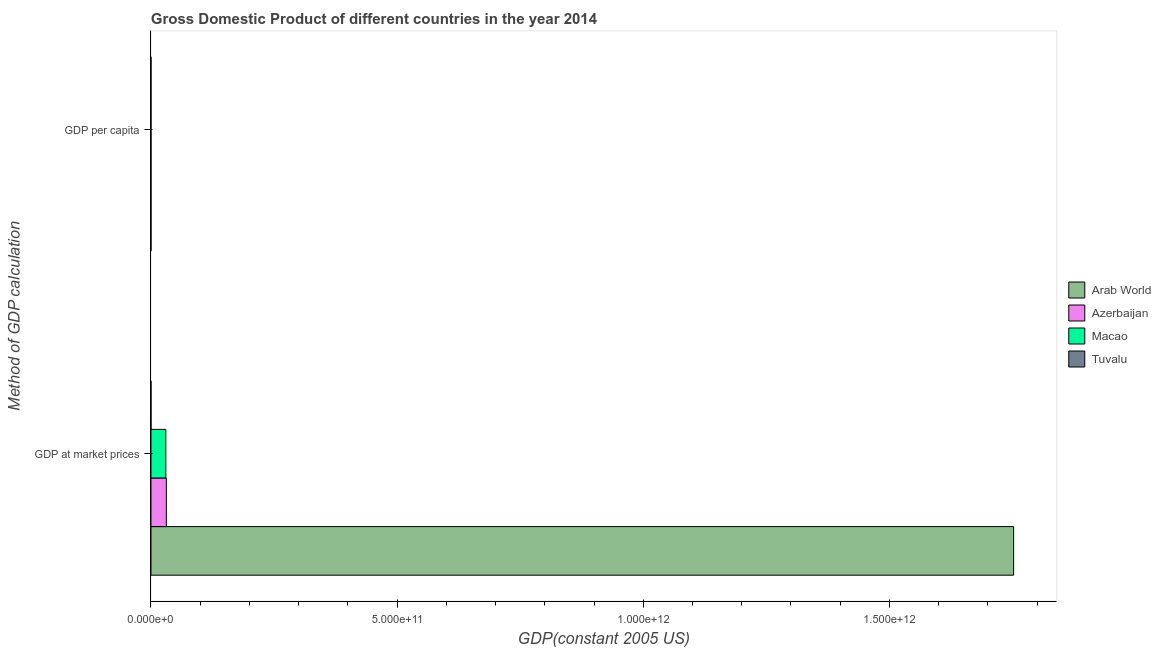Are the number of bars per tick equal to the number of legend labels?
Offer a terse response. Yes. How many bars are there on the 2nd tick from the top?
Keep it short and to the point. 4. What is the label of the 2nd group of bars from the top?
Ensure brevity in your answer.  GDP at market prices. What is the gdp at market prices in Arab World?
Keep it short and to the point. 1.75e+12. Across all countries, what is the maximum gdp at market prices?
Ensure brevity in your answer.  1.75e+12. Across all countries, what is the minimum gdp per capita?
Your answer should be compact. 2701.74. In which country was the gdp at market prices maximum?
Your answer should be compact. Arab World. In which country was the gdp at market prices minimum?
Give a very brief answer. Tuvalu. What is the total gdp per capita in the graph?
Your answer should be very brief. 6.28e+04. What is the difference between the gdp at market prices in Tuvalu and that in Macao?
Your answer should be very brief. -3.02e+1. What is the difference between the gdp at market prices in Azerbaijan and the gdp per capita in Tuvalu?
Offer a very short reply. 3.12e+1. What is the average gdp per capita per country?
Your answer should be very brief. 1.57e+04. What is the difference between the gdp at market prices and gdp per capita in Macao?
Give a very brief answer. 3.02e+1. In how many countries, is the gdp per capita greater than 1400000000000 US$?
Provide a short and direct response. 0. What is the ratio of the gdp at market prices in Arab World to that in Tuvalu?
Your answer should be compact. 6.56e+04. Is the gdp per capita in Macao less than that in Azerbaijan?
Your answer should be compact. No. What does the 1st bar from the top in GDP at market prices represents?
Offer a terse response. Tuvalu. What does the 1st bar from the bottom in GDP per capita represents?
Make the answer very short. Arab World. How many bars are there?
Your response must be concise. 8. How many countries are there in the graph?
Provide a short and direct response. 4. What is the difference between two consecutive major ticks on the X-axis?
Make the answer very short. 5.00e+11. Are the values on the major ticks of X-axis written in scientific E-notation?
Provide a succinct answer. Yes. Does the graph contain any zero values?
Ensure brevity in your answer.  No. Does the graph contain grids?
Keep it short and to the point. No. Where does the legend appear in the graph?
Provide a short and direct response. Center right. How many legend labels are there?
Offer a very short reply. 4. How are the legend labels stacked?
Keep it short and to the point. Vertical. What is the title of the graph?
Keep it short and to the point. Gross Domestic Product of different countries in the year 2014. What is the label or title of the X-axis?
Make the answer very short. GDP(constant 2005 US). What is the label or title of the Y-axis?
Provide a short and direct response. Method of GDP calculation. What is the GDP(constant 2005 US) of Arab World in GDP at market prices?
Keep it short and to the point. 1.75e+12. What is the GDP(constant 2005 US) in Azerbaijan in GDP at market prices?
Ensure brevity in your answer.  3.12e+1. What is the GDP(constant 2005 US) in Macao in GDP at market prices?
Give a very brief answer. 3.02e+1. What is the GDP(constant 2005 US) of Tuvalu in GDP at market prices?
Give a very brief answer. 2.67e+07. What is the GDP(constant 2005 US) in Arab World in GDP per capita?
Keep it short and to the point. 4548.53. What is the GDP(constant 2005 US) in Azerbaijan in GDP per capita?
Offer a very short reply. 3275.71. What is the GDP(constant 2005 US) of Macao in GDP per capita?
Offer a terse response. 5.23e+04. What is the GDP(constant 2005 US) of Tuvalu in GDP per capita?
Your answer should be very brief. 2701.74. Across all Method of GDP calculation, what is the maximum GDP(constant 2005 US) of Arab World?
Make the answer very short. 1.75e+12. Across all Method of GDP calculation, what is the maximum GDP(constant 2005 US) of Azerbaijan?
Your answer should be compact. 3.12e+1. Across all Method of GDP calculation, what is the maximum GDP(constant 2005 US) in Macao?
Ensure brevity in your answer.  3.02e+1. Across all Method of GDP calculation, what is the maximum GDP(constant 2005 US) of Tuvalu?
Ensure brevity in your answer.  2.67e+07. Across all Method of GDP calculation, what is the minimum GDP(constant 2005 US) of Arab World?
Make the answer very short. 4548.53. Across all Method of GDP calculation, what is the minimum GDP(constant 2005 US) of Azerbaijan?
Your answer should be compact. 3275.71. Across all Method of GDP calculation, what is the minimum GDP(constant 2005 US) in Macao?
Offer a very short reply. 5.23e+04. Across all Method of GDP calculation, what is the minimum GDP(constant 2005 US) of Tuvalu?
Offer a terse response. 2701.74. What is the total GDP(constant 2005 US) of Arab World in the graph?
Provide a short and direct response. 1.75e+12. What is the total GDP(constant 2005 US) in Azerbaijan in the graph?
Provide a succinct answer. 3.12e+1. What is the total GDP(constant 2005 US) in Macao in the graph?
Your response must be concise. 3.02e+1. What is the total GDP(constant 2005 US) in Tuvalu in the graph?
Your answer should be compact. 2.67e+07. What is the difference between the GDP(constant 2005 US) of Arab World in GDP at market prices and that in GDP per capita?
Make the answer very short. 1.75e+12. What is the difference between the GDP(constant 2005 US) of Azerbaijan in GDP at market prices and that in GDP per capita?
Offer a terse response. 3.12e+1. What is the difference between the GDP(constant 2005 US) of Macao in GDP at market prices and that in GDP per capita?
Your answer should be very brief. 3.02e+1. What is the difference between the GDP(constant 2005 US) in Tuvalu in GDP at market prices and that in GDP per capita?
Provide a succinct answer. 2.67e+07. What is the difference between the GDP(constant 2005 US) in Arab World in GDP at market prices and the GDP(constant 2005 US) in Azerbaijan in GDP per capita?
Give a very brief answer. 1.75e+12. What is the difference between the GDP(constant 2005 US) in Arab World in GDP at market prices and the GDP(constant 2005 US) in Macao in GDP per capita?
Offer a terse response. 1.75e+12. What is the difference between the GDP(constant 2005 US) of Arab World in GDP at market prices and the GDP(constant 2005 US) of Tuvalu in GDP per capita?
Your response must be concise. 1.75e+12. What is the difference between the GDP(constant 2005 US) of Azerbaijan in GDP at market prices and the GDP(constant 2005 US) of Macao in GDP per capita?
Your response must be concise. 3.12e+1. What is the difference between the GDP(constant 2005 US) in Azerbaijan in GDP at market prices and the GDP(constant 2005 US) in Tuvalu in GDP per capita?
Ensure brevity in your answer.  3.12e+1. What is the difference between the GDP(constant 2005 US) of Macao in GDP at market prices and the GDP(constant 2005 US) of Tuvalu in GDP per capita?
Give a very brief answer. 3.02e+1. What is the average GDP(constant 2005 US) of Arab World per Method of GDP calculation?
Provide a short and direct response. 8.76e+11. What is the average GDP(constant 2005 US) in Azerbaijan per Method of GDP calculation?
Offer a terse response. 1.56e+1. What is the average GDP(constant 2005 US) in Macao per Method of GDP calculation?
Keep it short and to the point. 1.51e+1. What is the average GDP(constant 2005 US) in Tuvalu per Method of GDP calculation?
Keep it short and to the point. 1.34e+07. What is the difference between the GDP(constant 2005 US) of Arab World and GDP(constant 2005 US) of Azerbaijan in GDP at market prices?
Offer a very short reply. 1.72e+12. What is the difference between the GDP(constant 2005 US) of Arab World and GDP(constant 2005 US) of Macao in GDP at market prices?
Make the answer very short. 1.72e+12. What is the difference between the GDP(constant 2005 US) in Arab World and GDP(constant 2005 US) in Tuvalu in GDP at market prices?
Make the answer very short. 1.75e+12. What is the difference between the GDP(constant 2005 US) in Azerbaijan and GDP(constant 2005 US) in Macao in GDP at market prices?
Offer a very short reply. 1.04e+09. What is the difference between the GDP(constant 2005 US) of Azerbaijan and GDP(constant 2005 US) of Tuvalu in GDP at market prices?
Provide a short and direct response. 3.12e+1. What is the difference between the GDP(constant 2005 US) in Macao and GDP(constant 2005 US) in Tuvalu in GDP at market prices?
Give a very brief answer. 3.02e+1. What is the difference between the GDP(constant 2005 US) of Arab World and GDP(constant 2005 US) of Azerbaijan in GDP per capita?
Offer a very short reply. 1272.82. What is the difference between the GDP(constant 2005 US) in Arab World and GDP(constant 2005 US) in Macao in GDP per capita?
Keep it short and to the point. -4.77e+04. What is the difference between the GDP(constant 2005 US) in Arab World and GDP(constant 2005 US) in Tuvalu in GDP per capita?
Provide a succinct answer. 1846.79. What is the difference between the GDP(constant 2005 US) of Azerbaijan and GDP(constant 2005 US) of Macao in GDP per capita?
Give a very brief answer. -4.90e+04. What is the difference between the GDP(constant 2005 US) of Azerbaijan and GDP(constant 2005 US) of Tuvalu in GDP per capita?
Your answer should be very brief. 573.98. What is the difference between the GDP(constant 2005 US) in Macao and GDP(constant 2005 US) in Tuvalu in GDP per capita?
Ensure brevity in your answer.  4.96e+04. What is the ratio of the GDP(constant 2005 US) in Arab World in GDP at market prices to that in GDP per capita?
Provide a short and direct response. 3.85e+08. What is the ratio of the GDP(constant 2005 US) of Azerbaijan in GDP at market prices to that in GDP per capita?
Your answer should be very brief. 9.54e+06. What is the ratio of the GDP(constant 2005 US) of Macao in GDP at market prices to that in GDP per capita?
Offer a terse response. 5.78e+05. What is the ratio of the GDP(constant 2005 US) of Tuvalu in GDP at market prices to that in GDP per capita?
Offer a terse response. 9893. What is the difference between the highest and the second highest GDP(constant 2005 US) of Arab World?
Offer a terse response. 1.75e+12. What is the difference between the highest and the second highest GDP(constant 2005 US) in Azerbaijan?
Provide a short and direct response. 3.12e+1. What is the difference between the highest and the second highest GDP(constant 2005 US) in Macao?
Offer a terse response. 3.02e+1. What is the difference between the highest and the second highest GDP(constant 2005 US) of Tuvalu?
Provide a succinct answer. 2.67e+07. What is the difference between the highest and the lowest GDP(constant 2005 US) in Arab World?
Your response must be concise. 1.75e+12. What is the difference between the highest and the lowest GDP(constant 2005 US) of Azerbaijan?
Give a very brief answer. 3.12e+1. What is the difference between the highest and the lowest GDP(constant 2005 US) in Macao?
Your answer should be compact. 3.02e+1. What is the difference between the highest and the lowest GDP(constant 2005 US) of Tuvalu?
Your answer should be very brief. 2.67e+07. 